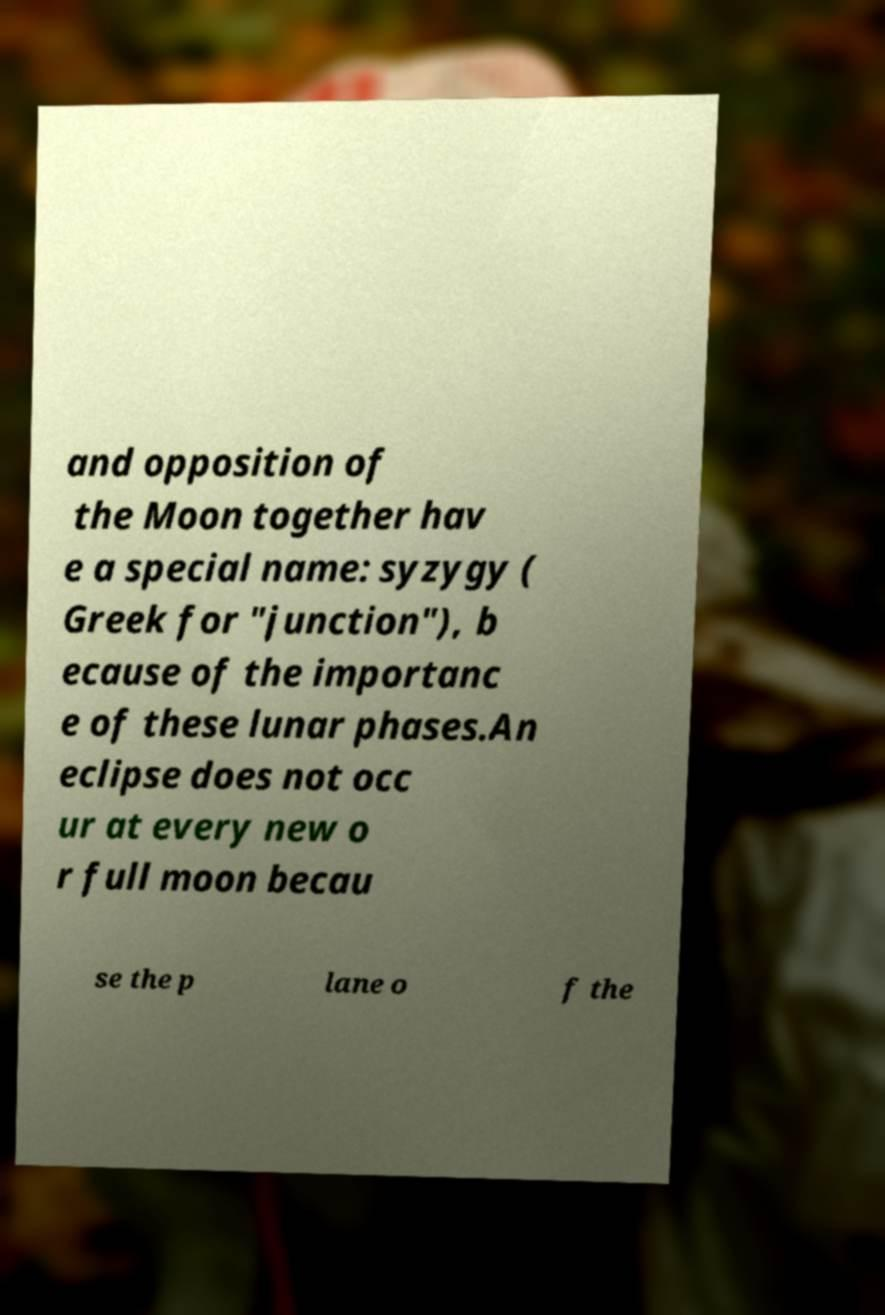Please identify and transcribe the text found in this image. and opposition of the Moon together hav e a special name: syzygy ( Greek for "junction"), b ecause of the importanc e of these lunar phases.An eclipse does not occ ur at every new o r full moon becau se the p lane o f the 